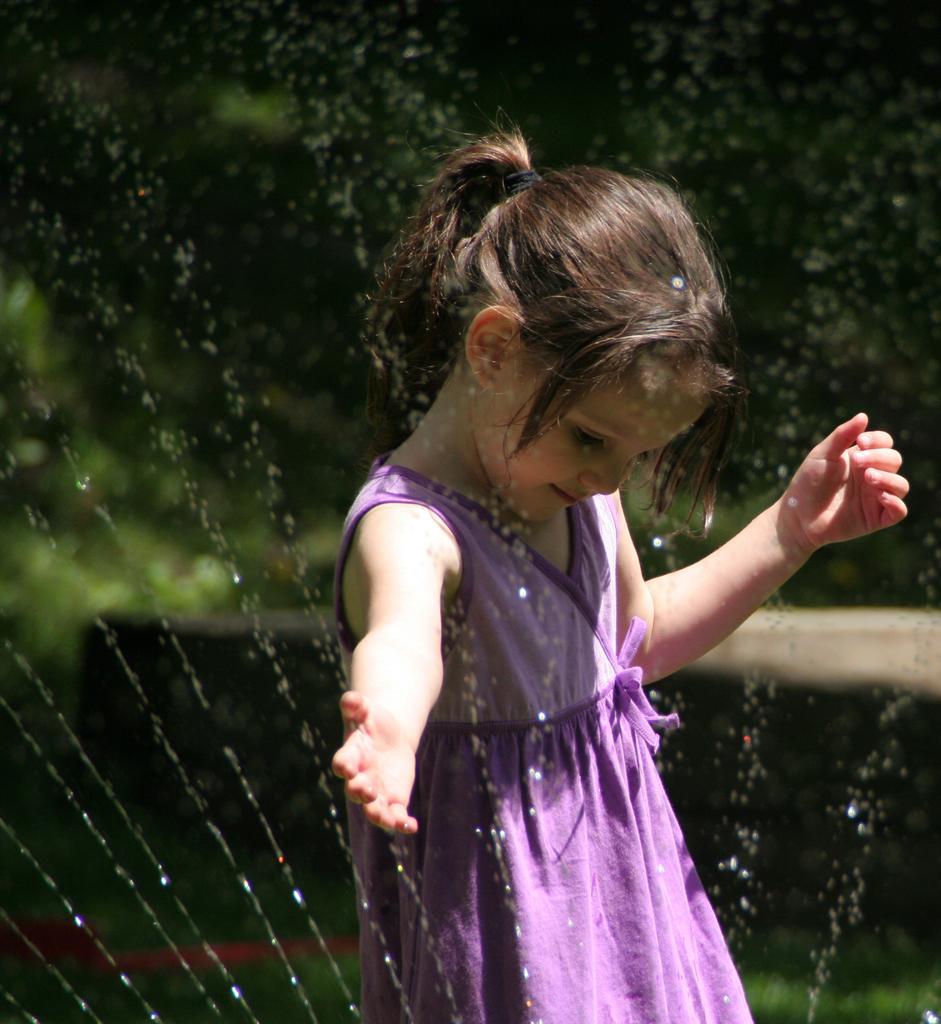How would you summarize this image in a sentence or two? In this image, we can see a kid and some water sprinkles. In the background, image is blurred. 